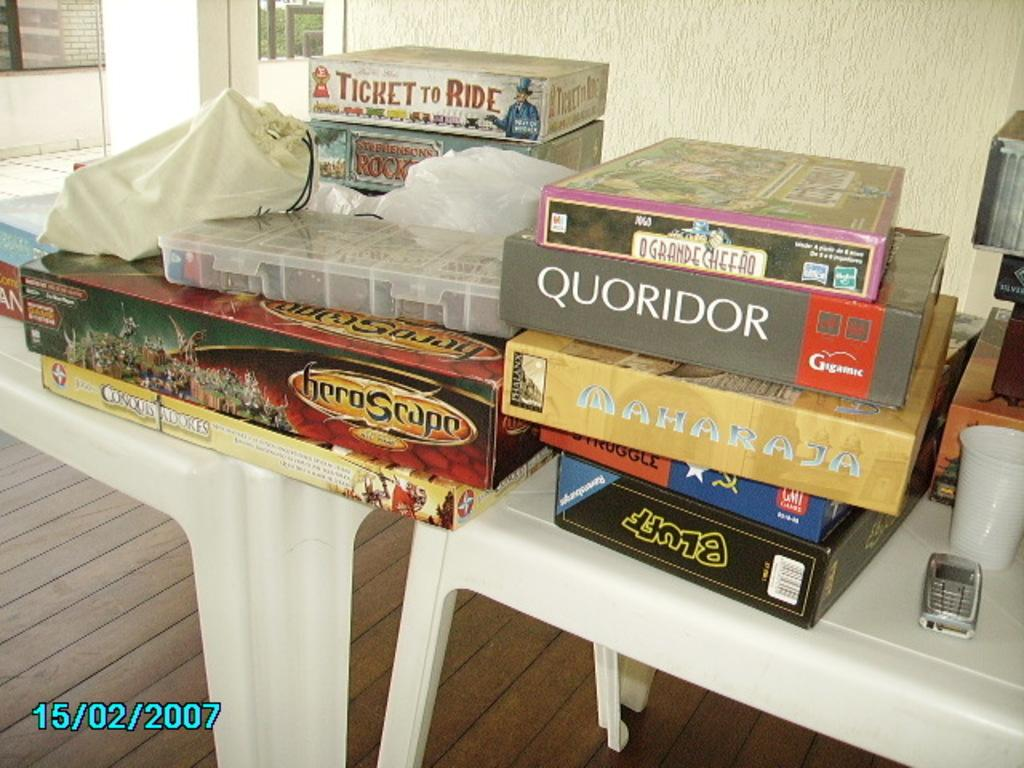What type of containers are in the image? There are cardboard boxes in the image. What electronic device can be seen in the image? A cell phone is visible in the image. What type of glasses are present in the image? Disposal glasses are present in the image. What is on the table in the image? There is cloth on the table in the image. What can be seen in the background of the image? There is a wall and trees in the background of the image. Where is the frog sitting in the image? There is no frog present in the image. What type of gun can be seen in the image? There is no gun present in the image. 